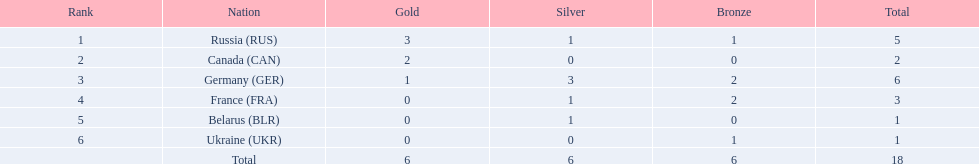What were the only 3 countries to win gold medals at the the 1994 winter olympics biathlon? Russia (RUS), Canada (CAN), Germany (GER). 